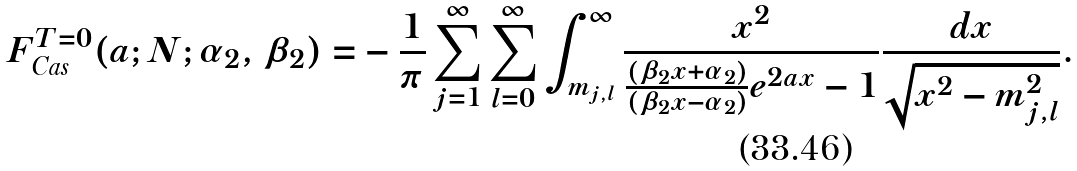Convert formula to latex. <formula><loc_0><loc_0><loc_500><loc_500>F _ { \text {Cas} } ^ { T = 0 } ( a ; N ; \alpha _ { 2 } , \beta _ { 2 } ) = & - \frac { 1 } { \pi } \sum _ { j = 1 } ^ { \infty } \sum _ { l = 0 } ^ { \infty } \int _ { m _ { j , l } } ^ { \infty } \frac { x ^ { 2 } } { \frac { \left ( \beta _ { 2 } x + \alpha _ { 2 } \right ) } { \left ( \beta _ { 2 } x - \alpha _ { 2 } \right ) } e ^ { 2 a x } - 1 } \frac { d x } { \sqrt { x ^ { 2 } - m _ { j , l } ^ { 2 } } } .</formula> 